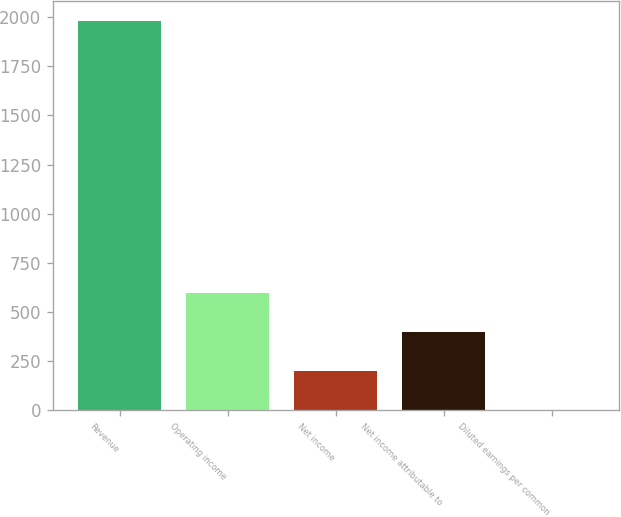Convert chart. <chart><loc_0><loc_0><loc_500><loc_500><bar_chart><fcel>Revenue<fcel>Operating income<fcel>Net income<fcel>Net income attributable to<fcel>Diluted earnings per common<nl><fcel>1982.4<fcel>594.98<fcel>198.58<fcel>396.78<fcel>0.38<nl></chart> 